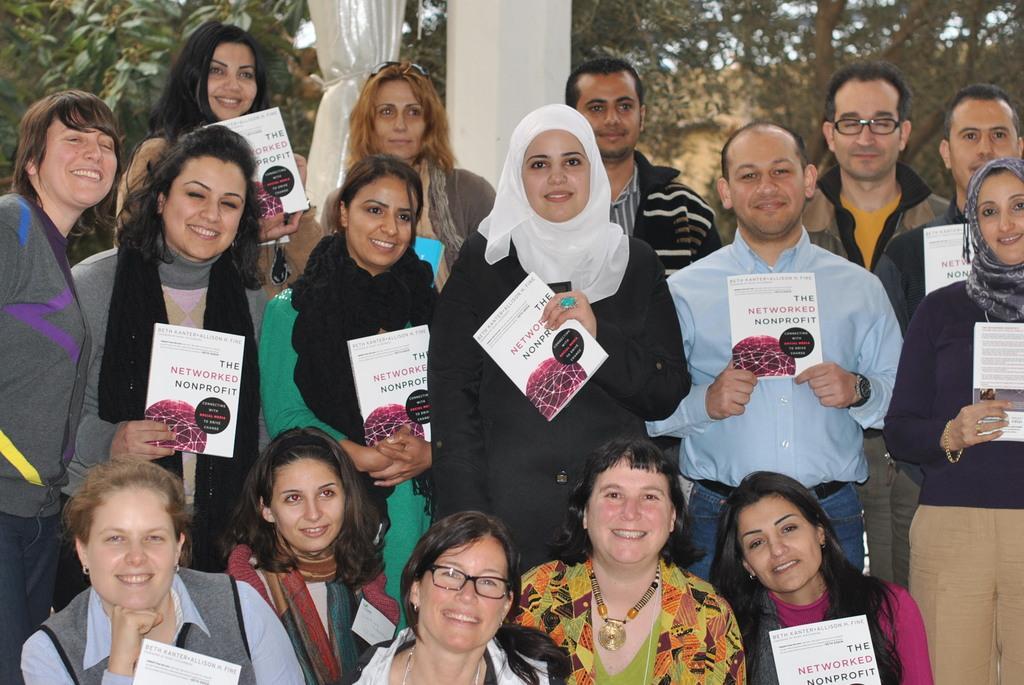Describe this image in one or two sentences. In this picture, it seems like people holding pamphlets in their hands in the foreground, there are trees, curtain, pillar and the sky in the background. 